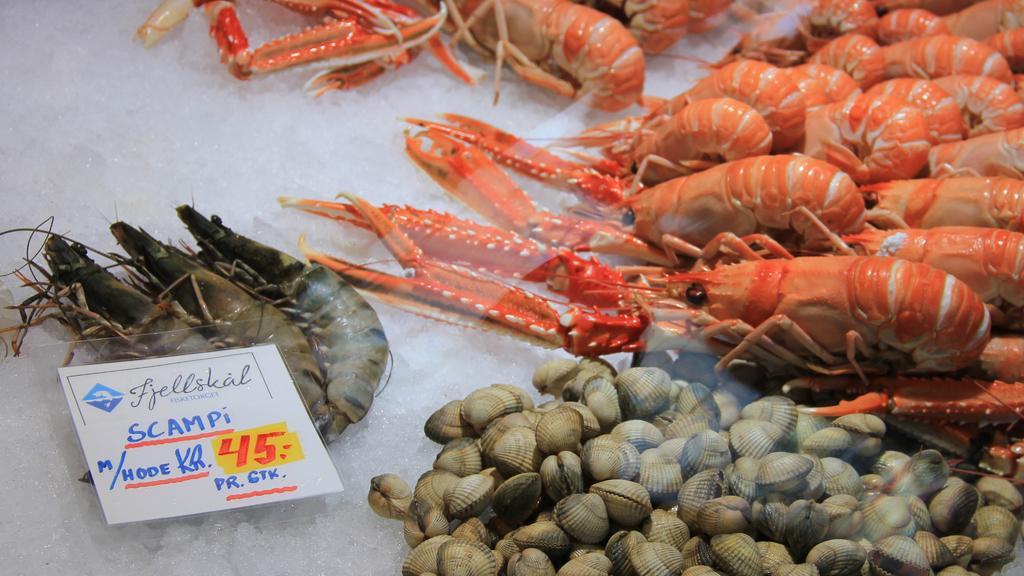Could you give a brief overview of what you see in this image? In this image I can see number of orange colour prawns. On the right bottom side I can see number of shells. On the left side of this image I can see few prawns and a white colour board. On this board I can see something is written. 